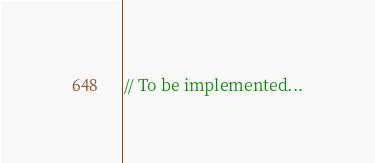<code> <loc_0><loc_0><loc_500><loc_500><_Rust_>// To be implemented...</code> 